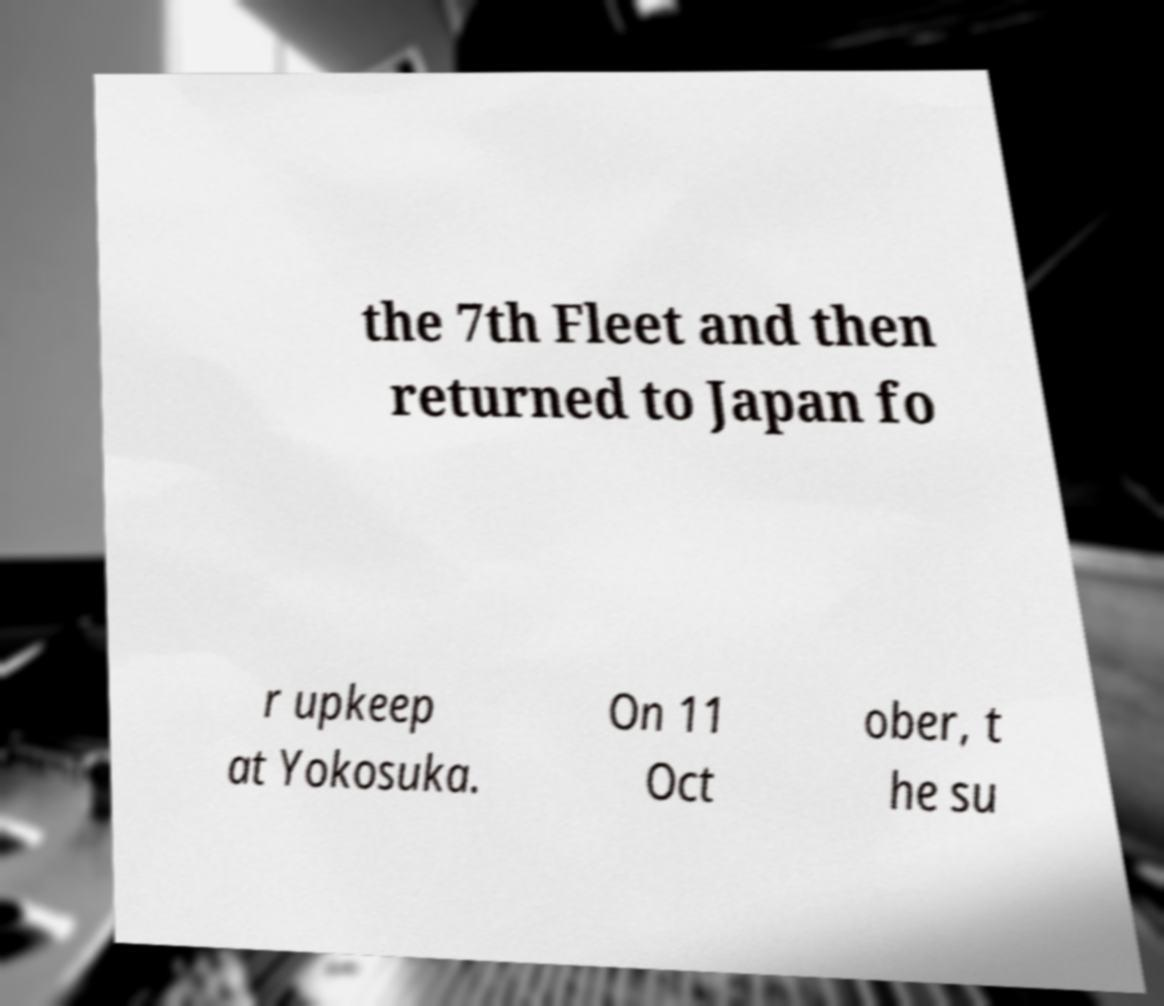I need the written content from this picture converted into text. Can you do that? the 7th Fleet and then returned to Japan fo r upkeep at Yokosuka. On 11 Oct ober, t he su 